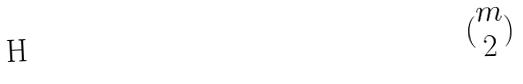Convert formula to latex. <formula><loc_0><loc_0><loc_500><loc_500>( \begin{matrix} m \\ 2 \end{matrix} )</formula> 